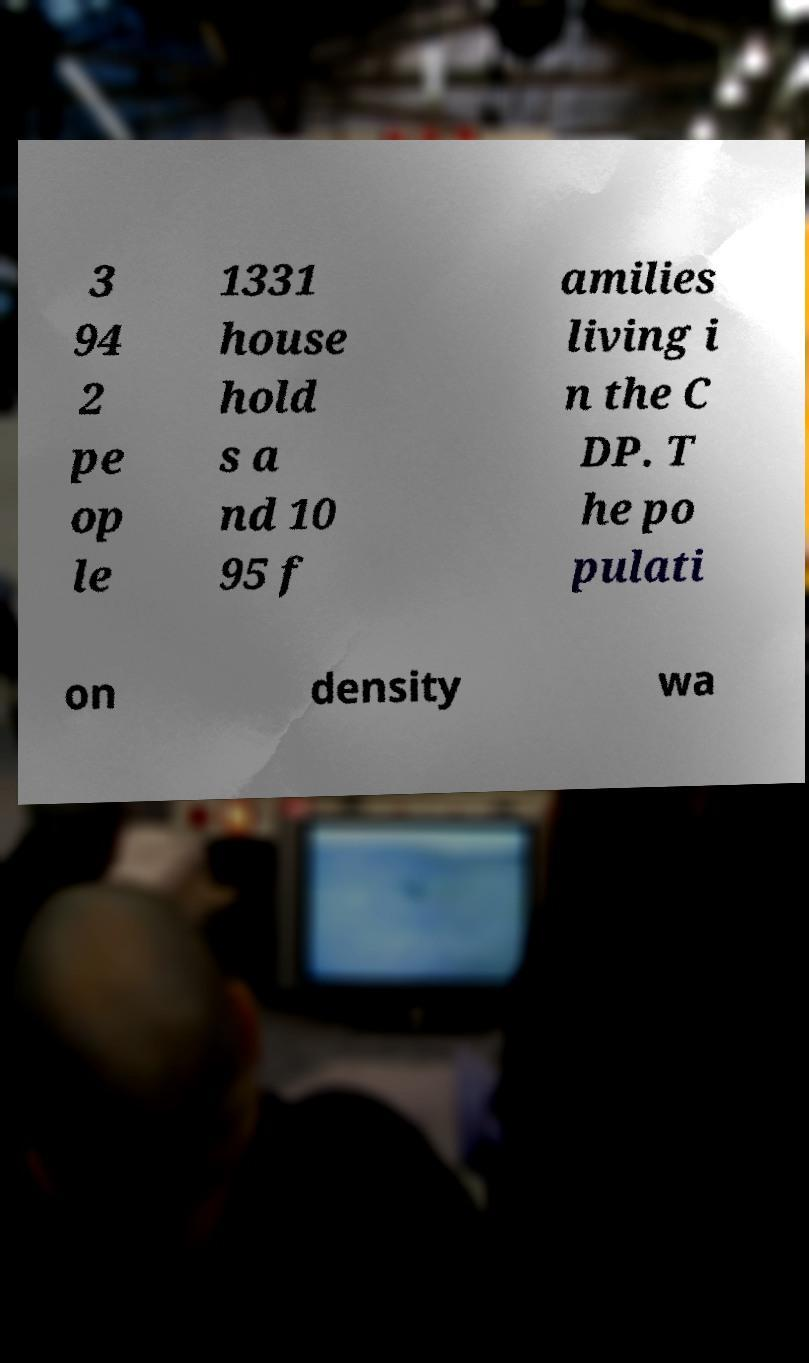I need the written content from this picture converted into text. Can you do that? 3 94 2 pe op le 1331 house hold s a nd 10 95 f amilies living i n the C DP. T he po pulati on density wa 